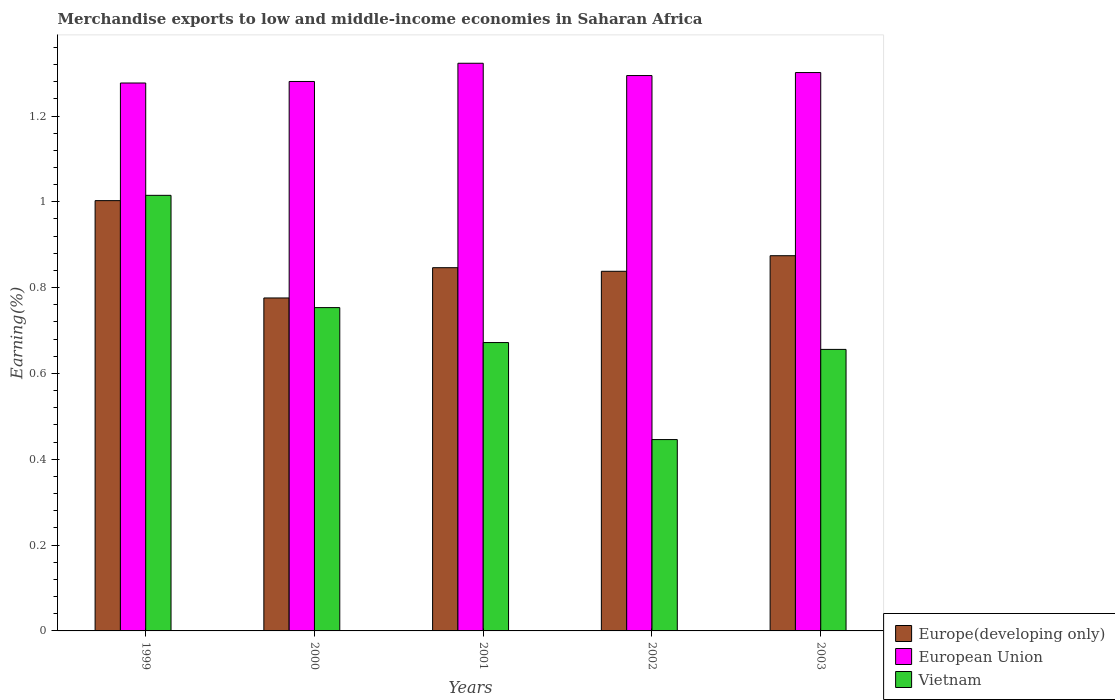Are the number of bars per tick equal to the number of legend labels?
Offer a very short reply. Yes. How many bars are there on the 1st tick from the left?
Your answer should be very brief. 3. In how many cases, is the number of bars for a given year not equal to the number of legend labels?
Make the answer very short. 0. What is the percentage of amount earned from merchandise exports in Vietnam in 2003?
Offer a very short reply. 0.66. Across all years, what is the maximum percentage of amount earned from merchandise exports in Europe(developing only)?
Ensure brevity in your answer.  1. Across all years, what is the minimum percentage of amount earned from merchandise exports in Vietnam?
Provide a succinct answer. 0.45. In which year was the percentage of amount earned from merchandise exports in Europe(developing only) maximum?
Your answer should be compact. 1999. In which year was the percentage of amount earned from merchandise exports in Europe(developing only) minimum?
Provide a short and direct response. 2000. What is the total percentage of amount earned from merchandise exports in Vietnam in the graph?
Your response must be concise. 3.54. What is the difference between the percentage of amount earned from merchandise exports in European Union in 2002 and that in 2003?
Offer a very short reply. -0.01. What is the difference between the percentage of amount earned from merchandise exports in Europe(developing only) in 2003 and the percentage of amount earned from merchandise exports in European Union in 2002?
Your answer should be compact. -0.42. What is the average percentage of amount earned from merchandise exports in European Union per year?
Your response must be concise. 1.3. In the year 2000, what is the difference between the percentage of amount earned from merchandise exports in Vietnam and percentage of amount earned from merchandise exports in Europe(developing only)?
Give a very brief answer. -0.02. What is the ratio of the percentage of amount earned from merchandise exports in Europe(developing only) in 2001 to that in 2002?
Make the answer very short. 1.01. Is the percentage of amount earned from merchandise exports in Europe(developing only) in 2000 less than that in 2002?
Your response must be concise. Yes. Is the difference between the percentage of amount earned from merchandise exports in Vietnam in 2000 and 2003 greater than the difference between the percentage of amount earned from merchandise exports in Europe(developing only) in 2000 and 2003?
Offer a terse response. Yes. What is the difference between the highest and the second highest percentage of amount earned from merchandise exports in Vietnam?
Provide a succinct answer. 0.26. What is the difference between the highest and the lowest percentage of amount earned from merchandise exports in Europe(developing only)?
Ensure brevity in your answer.  0.23. What does the 1st bar from the left in 2003 represents?
Provide a short and direct response. Europe(developing only). What does the 1st bar from the right in 2003 represents?
Keep it short and to the point. Vietnam. How many years are there in the graph?
Offer a terse response. 5. Where does the legend appear in the graph?
Keep it short and to the point. Bottom right. What is the title of the graph?
Your response must be concise. Merchandise exports to low and middle-income economies in Saharan Africa. What is the label or title of the X-axis?
Provide a succinct answer. Years. What is the label or title of the Y-axis?
Offer a very short reply. Earning(%). What is the Earning(%) of Europe(developing only) in 1999?
Your answer should be compact. 1. What is the Earning(%) of European Union in 1999?
Give a very brief answer. 1.28. What is the Earning(%) of Vietnam in 1999?
Ensure brevity in your answer.  1.02. What is the Earning(%) in Europe(developing only) in 2000?
Give a very brief answer. 0.78. What is the Earning(%) of European Union in 2000?
Provide a succinct answer. 1.28. What is the Earning(%) in Vietnam in 2000?
Make the answer very short. 0.75. What is the Earning(%) of Europe(developing only) in 2001?
Keep it short and to the point. 0.85. What is the Earning(%) of European Union in 2001?
Make the answer very short. 1.32. What is the Earning(%) in Vietnam in 2001?
Provide a short and direct response. 0.67. What is the Earning(%) in Europe(developing only) in 2002?
Give a very brief answer. 0.84. What is the Earning(%) of European Union in 2002?
Offer a terse response. 1.29. What is the Earning(%) of Vietnam in 2002?
Your answer should be very brief. 0.45. What is the Earning(%) of Europe(developing only) in 2003?
Your response must be concise. 0.87. What is the Earning(%) of European Union in 2003?
Make the answer very short. 1.3. What is the Earning(%) in Vietnam in 2003?
Provide a succinct answer. 0.66. Across all years, what is the maximum Earning(%) in Europe(developing only)?
Ensure brevity in your answer.  1. Across all years, what is the maximum Earning(%) in European Union?
Provide a short and direct response. 1.32. Across all years, what is the maximum Earning(%) of Vietnam?
Offer a very short reply. 1.02. Across all years, what is the minimum Earning(%) of Europe(developing only)?
Keep it short and to the point. 0.78. Across all years, what is the minimum Earning(%) of European Union?
Make the answer very short. 1.28. Across all years, what is the minimum Earning(%) of Vietnam?
Your response must be concise. 0.45. What is the total Earning(%) of Europe(developing only) in the graph?
Your answer should be compact. 4.34. What is the total Earning(%) of European Union in the graph?
Your response must be concise. 6.48. What is the total Earning(%) in Vietnam in the graph?
Provide a short and direct response. 3.54. What is the difference between the Earning(%) of Europe(developing only) in 1999 and that in 2000?
Your answer should be compact. 0.23. What is the difference between the Earning(%) in European Union in 1999 and that in 2000?
Make the answer very short. -0. What is the difference between the Earning(%) of Vietnam in 1999 and that in 2000?
Keep it short and to the point. 0.26. What is the difference between the Earning(%) in Europe(developing only) in 1999 and that in 2001?
Your answer should be very brief. 0.16. What is the difference between the Earning(%) in European Union in 1999 and that in 2001?
Your answer should be compact. -0.05. What is the difference between the Earning(%) of Vietnam in 1999 and that in 2001?
Provide a succinct answer. 0.34. What is the difference between the Earning(%) of Europe(developing only) in 1999 and that in 2002?
Provide a succinct answer. 0.16. What is the difference between the Earning(%) of European Union in 1999 and that in 2002?
Ensure brevity in your answer.  -0.02. What is the difference between the Earning(%) in Vietnam in 1999 and that in 2002?
Your answer should be very brief. 0.57. What is the difference between the Earning(%) of Europe(developing only) in 1999 and that in 2003?
Provide a succinct answer. 0.13. What is the difference between the Earning(%) of European Union in 1999 and that in 2003?
Offer a terse response. -0.02. What is the difference between the Earning(%) in Vietnam in 1999 and that in 2003?
Keep it short and to the point. 0.36. What is the difference between the Earning(%) in Europe(developing only) in 2000 and that in 2001?
Provide a short and direct response. -0.07. What is the difference between the Earning(%) in European Union in 2000 and that in 2001?
Provide a short and direct response. -0.04. What is the difference between the Earning(%) of Vietnam in 2000 and that in 2001?
Keep it short and to the point. 0.08. What is the difference between the Earning(%) in Europe(developing only) in 2000 and that in 2002?
Offer a very short reply. -0.06. What is the difference between the Earning(%) of European Union in 2000 and that in 2002?
Offer a very short reply. -0.01. What is the difference between the Earning(%) of Vietnam in 2000 and that in 2002?
Your answer should be very brief. 0.31. What is the difference between the Earning(%) of Europe(developing only) in 2000 and that in 2003?
Make the answer very short. -0.1. What is the difference between the Earning(%) of European Union in 2000 and that in 2003?
Your answer should be compact. -0.02. What is the difference between the Earning(%) of Vietnam in 2000 and that in 2003?
Provide a succinct answer. 0.1. What is the difference between the Earning(%) of Europe(developing only) in 2001 and that in 2002?
Ensure brevity in your answer.  0.01. What is the difference between the Earning(%) in European Union in 2001 and that in 2002?
Provide a succinct answer. 0.03. What is the difference between the Earning(%) of Vietnam in 2001 and that in 2002?
Give a very brief answer. 0.23. What is the difference between the Earning(%) of Europe(developing only) in 2001 and that in 2003?
Keep it short and to the point. -0.03. What is the difference between the Earning(%) of European Union in 2001 and that in 2003?
Give a very brief answer. 0.02. What is the difference between the Earning(%) in Vietnam in 2001 and that in 2003?
Your answer should be compact. 0.02. What is the difference between the Earning(%) in Europe(developing only) in 2002 and that in 2003?
Give a very brief answer. -0.04. What is the difference between the Earning(%) of European Union in 2002 and that in 2003?
Make the answer very short. -0.01. What is the difference between the Earning(%) in Vietnam in 2002 and that in 2003?
Provide a short and direct response. -0.21. What is the difference between the Earning(%) of Europe(developing only) in 1999 and the Earning(%) of European Union in 2000?
Ensure brevity in your answer.  -0.28. What is the difference between the Earning(%) in Europe(developing only) in 1999 and the Earning(%) in Vietnam in 2000?
Your response must be concise. 0.25. What is the difference between the Earning(%) of European Union in 1999 and the Earning(%) of Vietnam in 2000?
Offer a very short reply. 0.52. What is the difference between the Earning(%) in Europe(developing only) in 1999 and the Earning(%) in European Union in 2001?
Provide a succinct answer. -0.32. What is the difference between the Earning(%) in Europe(developing only) in 1999 and the Earning(%) in Vietnam in 2001?
Offer a terse response. 0.33. What is the difference between the Earning(%) in European Union in 1999 and the Earning(%) in Vietnam in 2001?
Offer a very short reply. 0.6. What is the difference between the Earning(%) in Europe(developing only) in 1999 and the Earning(%) in European Union in 2002?
Your response must be concise. -0.29. What is the difference between the Earning(%) of Europe(developing only) in 1999 and the Earning(%) of Vietnam in 2002?
Give a very brief answer. 0.56. What is the difference between the Earning(%) in European Union in 1999 and the Earning(%) in Vietnam in 2002?
Give a very brief answer. 0.83. What is the difference between the Earning(%) in Europe(developing only) in 1999 and the Earning(%) in European Union in 2003?
Make the answer very short. -0.3. What is the difference between the Earning(%) of Europe(developing only) in 1999 and the Earning(%) of Vietnam in 2003?
Provide a succinct answer. 0.35. What is the difference between the Earning(%) of European Union in 1999 and the Earning(%) of Vietnam in 2003?
Make the answer very short. 0.62. What is the difference between the Earning(%) of Europe(developing only) in 2000 and the Earning(%) of European Union in 2001?
Your response must be concise. -0.55. What is the difference between the Earning(%) of Europe(developing only) in 2000 and the Earning(%) of Vietnam in 2001?
Offer a terse response. 0.1. What is the difference between the Earning(%) of European Union in 2000 and the Earning(%) of Vietnam in 2001?
Provide a succinct answer. 0.61. What is the difference between the Earning(%) in Europe(developing only) in 2000 and the Earning(%) in European Union in 2002?
Provide a short and direct response. -0.52. What is the difference between the Earning(%) in Europe(developing only) in 2000 and the Earning(%) in Vietnam in 2002?
Keep it short and to the point. 0.33. What is the difference between the Earning(%) in European Union in 2000 and the Earning(%) in Vietnam in 2002?
Your response must be concise. 0.83. What is the difference between the Earning(%) in Europe(developing only) in 2000 and the Earning(%) in European Union in 2003?
Ensure brevity in your answer.  -0.53. What is the difference between the Earning(%) of Europe(developing only) in 2000 and the Earning(%) of Vietnam in 2003?
Provide a short and direct response. 0.12. What is the difference between the Earning(%) of European Union in 2000 and the Earning(%) of Vietnam in 2003?
Provide a succinct answer. 0.62. What is the difference between the Earning(%) in Europe(developing only) in 2001 and the Earning(%) in European Union in 2002?
Keep it short and to the point. -0.45. What is the difference between the Earning(%) in Europe(developing only) in 2001 and the Earning(%) in Vietnam in 2002?
Provide a succinct answer. 0.4. What is the difference between the Earning(%) of European Union in 2001 and the Earning(%) of Vietnam in 2002?
Give a very brief answer. 0.88. What is the difference between the Earning(%) in Europe(developing only) in 2001 and the Earning(%) in European Union in 2003?
Keep it short and to the point. -0.45. What is the difference between the Earning(%) in Europe(developing only) in 2001 and the Earning(%) in Vietnam in 2003?
Offer a very short reply. 0.19. What is the difference between the Earning(%) of European Union in 2001 and the Earning(%) of Vietnam in 2003?
Offer a terse response. 0.67. What is the difference between the Earning(%) of Europe(developing only) in 2002 and the Earning(%) of European Union in 2003?
Your response must be concise. -0.46. What is the difference between the Earning(%) in Europe(developing only) in 2002 and the Earning(%) in Vietnam in 2003?
Make the answer very short. 0.18. What is the difference between the Earning(%) of European Union in 2002 and the Earning(%) of Vietnam in 2003?
Provide a succinct answer. 0.64. What is the average Earning(%) of Europe(developing only) per year?
Offer a terse response. 0.87. What is the average Earning(%) of European Union per year?
Provide a succinct answer. 1.3. What is the average Earning(%) of Vietnam per year?
Your answer should be very brief. 0.71. In the year 1999, what is the difference between the Earning(%) in Europe(developing only) and Earning(%) in European Union?
Keep it short and to the point. -0.27. In the year 1999, what is the difference between the Earning(%) in Europe(developing only) and Earning(%) in Vietnam?
Your answer should be compact. -0.01. In the year 1999, what is the difference between the Earning(%) in European Union and Earning(%) in Vietnam?
Your answer should be compact. 0.26. In the year 2000, what is the difference between the Earning(%) in Europe(developing only) and Earning(%) in European Union?
Your answer should be very brief. -0.5. In the year 2000, what is the difference between the Earning(%) of Europe(developing only) and Earning(%) of Vietnam?
Your answer should be very brief. 0.02. In the year 2000, what is the difference between the Earning(%) of European Union and Earning(%) of Vietnam?
Your answer should be compact. 0.53. In the year 2001, what is the difference between the Earning(%) of Europe(developing only) and Earning(%) of European Union?
Keep it short and to the point. -0.48. In the year 2001, what is the difference between the Earning(%) in Europe(developing only) and Earning(%) in Vietnam?
Provide a succinct answer. 0.17. In the year 2001, what is the difference between the Earning(%) in European Union and Earning(%) in Vietnam?
Offer a very short reply. 0.65. In the year 2002, what is the difference between the Earning(%) in Europe(developing only) and Earning(%) in European Union?
Provide a succinct answer. -0.46. In the year 2002, what is the difference between the Earning(%) of Europe(developing only) and Earning(%) of Vietnam?
Provide a short and direct response. 0.39. In the year 2002, what is the difference between the Earning(%) of European Union and Earning(%) of Vietnam?
Make the answer very short. 0.85. In the year 2003, what is the difference between the Earning(%) of Europe(developing only) and Earning(%) of European Union?
Provide a succinct answer. -0.43. In the year 2003, what is the difference between the Earning(%) of Europe(developing only) and Earning(%) of Vietnam?
Offer a very short reply. 0.22. In the year 2003, what is the difference between the Earning(%) in European Union and Earning(%) in Vietnam?
Offer a very short reply. 0.65. What is the ratio of the Earning(%) in Europe(developing only) in 1999 to that in 2000?
Keep it short and to the point. 1.29. What is the ratio of the Earning(%) of European Union in 1999 to that in 2000?
Give a very brief answer. 1. What is the ratio of the Earning(%) of Vietnam in 1999 to that in 2000?
Give a very brief answer. 1.35. What is the ratio of the Earning(%) in Europe(developing only) in 1999 to that in 2001?
Keep it short and to the point. 1.18. What is the ratio of the Earning(%) in European Union in 1999 to that in 2001?
Offer a very short reply. 0.97. What is the ratio of the Earning(%) of Vietnam in 1999 to that in 2001?
Your answer should be compact. 1.51. What is the ratio of the Earning(%) of Europe(developing only) in 1999 to that in 2002?
Offer a very short reply. 1.2. What is the ratio of the Earning(%) in European Union in 1999 to that in 2002?
Make the answer very short. 0.99. What is the ratio of the Earning(%) in Vietnam in 1999 to that in 2002?
Offer a terse response. 2.28. What is the ratio of the Earning(%) in Europe(developing only) in 1999 to that in 2003?
Offer a very short reply. 1.15. What is the ratio of the Earning(%) in European Union in 1999 to that in 2003?
Provide a succinct answer. 0.98. What is the ratio of the Earning(%) in Vietnam in 1999 to that in 2003?
Give a very brief answer. 1.55. What is the ratio of the Earning(%) of Europe(developing only) in 2000 to that in 2001?
Offer a terse response. 0.92. What is the ratio of the Earning(%) of European Union in 2000 to that in 2001?
Offer a terse response. 0.97. What is the ratio of the Earning(%) in Vietnam in 2000 to that in 2001?
Provide a short and direct response. 1.12. What is the ratio of the Earning(%) in Europe(developing only) in 2000 to that in 2002?
Your answer should be compact. 0.93. What is the ratio of the Earning(%) of European Union in 2000 to that in 2002?
Offer a terse response. 0.99. What is the ratio of the Earning(%) in Vietnam in 2000 to that in 2002?
Provide a short and direct response. 1.69. What is the ratio of the Earning(%) of Europe(developing only) in 2000 to that in 2003?
Give a very brief answer. 0.89. What is the ratio of the Earning(%) in European Union in 2000 to that in 2003?
Your response must be concise. 0.98. What is the ratio of the Earning(%) in Vietnam in 2000 to that in 2003?
Offer a terse response. 1.15. What is the ratio of the Earning(%) of Europe(developing only) in 2001 to that in 2002?
Your answer should be compact. 1.01. What is the ratio of the Earning(%) of European Union in 2001 to that in 2002?
Your answer should be compact. 1.02. What is the ratio of the Earning(%) in Vietnam in 2001 to that in 2002?
Make the answer very short. 1.51. What is the ratio of the Earning(%) of Europe(developing only) in 2001 to that in 2003?
Your answer should be compact. 0.97. What is the ratio of the Earning(%) of European Union in 2001 to that in 2003?
Keep it short and to the point. 1.02. What is the ratio of the Earning(%) in Vietnam in 2001 to that in 2003?
Your response must be concise. 1.02. What is the ratio of the Earning(%) of Europe(developing only) in 2002 to that in 2003?
Your response must be concise. 0.96. What is the ratio of the Earning(%) of Vietnam in 2002 to that in 2003?
Keep it short and to the point. 0.68. What is the difference between the highest and the second highest Earning(%) in Europe(developing only)?
Ensure brevity in your answer.  0.13. What is the difference between the highest and the second highest Earning(%) in European Union?
Ensure brevity in your answer.  0.02. What is the difference between the highest and the second highest Earning(%) in Vietnam?
Give a very brief answer. 0.26. What is the difference between the highest and the lowest Earning(%) in Europe(developing only)?
Your answer should be very brief. 0.23. What is the difference between the highest and the lowest Earning(%) of European Union?
Provide a short and direct response. 0.05. What is the difference between the highest and the lowest Earning(%) in Vietnam?
Ensure brevity in your answer.  0.57. 